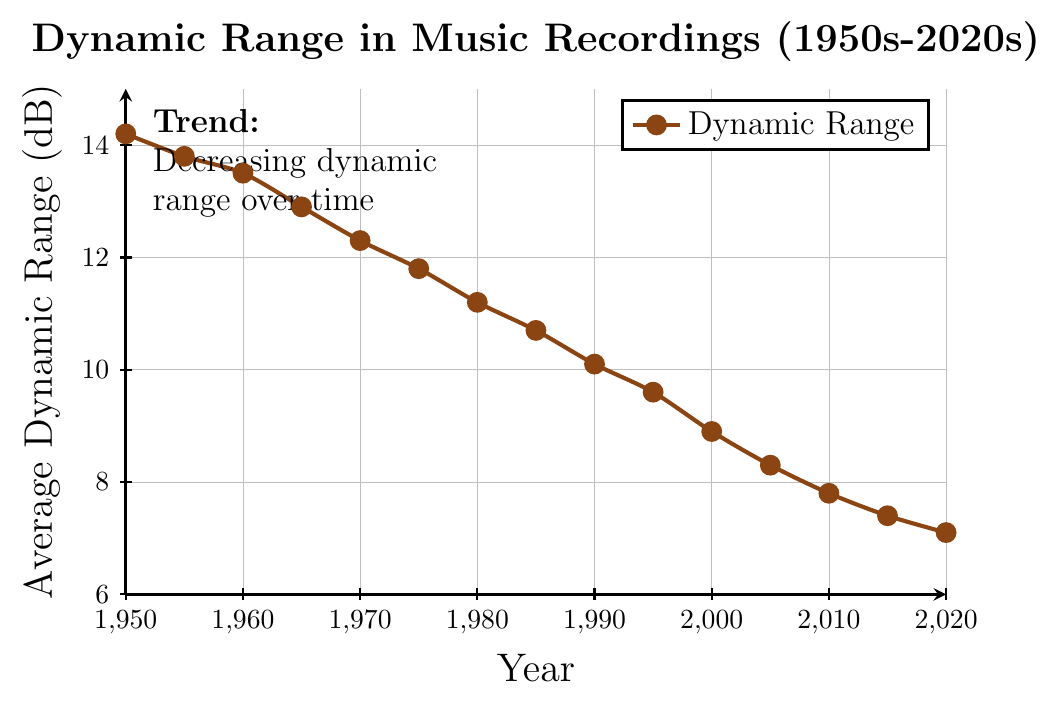what is the average dynamic range between 1950 and 1965? To find the average dynamic range, add the values from 1950 to 1965: 14.2 + 13.8 + 13.5 + 12.9 = 54.4. Then, divide the sum by the number of data points, which is 4: 54.4 / 4 = 13.6
Answer: 13.6 which year had the lowest average dynamic range? By examining the chart, we can see that 2020 had the lowest value with an average dynamic range of 7.1 dB
Answer: 2020 how much did the dynamic range decrease from 1950 to 2020? The dynamic range in 1950 was 14.2 dB, and in 2020, it was 7.1 dB. Subtract the later value from the earlier one: 14.2 - 7.1 = 7.1 dB
Answer: 7.1 dB during which decade did the dynamic range fall below 10 dB? The dynamic range fell below 10 dB in 1995, which was within the 1990s
Answer: 1990s is the dynamic range at any year greater than the initial value in 1950? By examining the chart, we can see that no year between 1950 and 2020 had a dynamic range greater than the initial value of 14.2 dB in 1950
Answer: No comparing the dynamic range between 1980 and 1990, in which year was it higher? The dynamic range in 1980 was 11.2 dB, while in 1990, it was 10.1 dB. Thus, 1980 has a higher value
Answer: 1980 what is the median dynamic range value for the entire period? To find the median, list the values in order: 7.1, 7.4, 7.8, 8.3, 8.9, 9.6, 10.1, 10.7, 11.2, 11.8, 12.3, 12.9, 13.5, 13.8, 14.2. The median is the middle value, which is 10.1
Answer: 10.1 how does the trend in dynamic range over time appear visually? The trend in dynamic range over time shows a clear and consistent decrease from 1950 to 2020, indicating a reduction in dynamic range throughout the years
Answer: Decreasing 